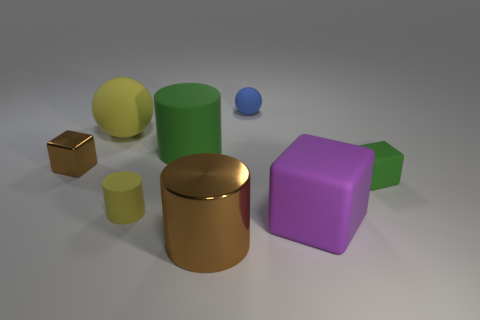Which object appears to be the smallest? The small blue sphere seems to be the smallest object among the collection, almost hidden in the scene. 